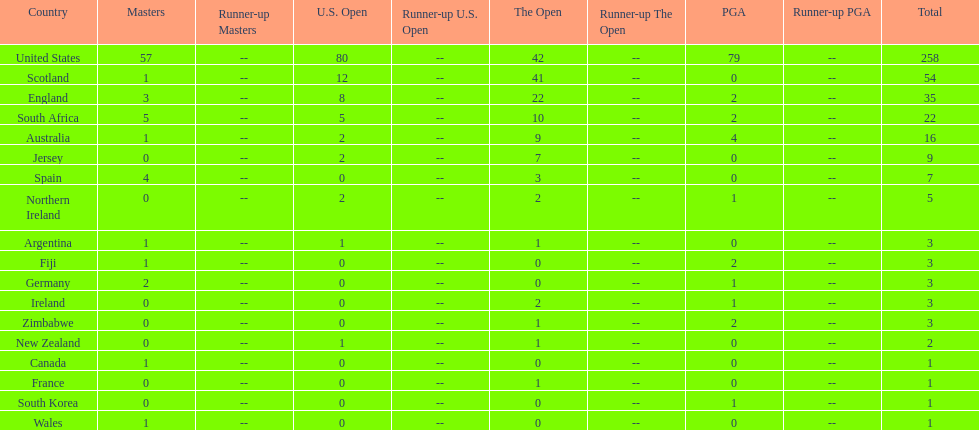How many u.s. open wins does fiji have? 0. Help me parse the entirety of this table. {'header': ['Country', 'Masters', 'Runner-up Masters', 'U.S. Open', 'Runner-up U.S. Open', 'The Open', 'Runner-up The Open', 'PGA', 'Runner-up PGA', 'Total'], 'rows': [['United States', '57', '--', '80', '--', '42', '--', '79', '--', '258'], ['Scotland', '1', '--', '12', '--', '41', '--', '0', '--', '54'], ['England', '3', '--', '8', '--', '22', '--', '2', '--', '35'], ['South Africa', '5', '--', '5', '--', '10', '--', '2', '--', '22'], ['Australia', '1', '--', '2', '--', '9', '--', '4', '--', '16'], ['Jersey', '0', '--', '2', '--', '7', '--', '0', '--', '9'], ['Spain', '4', '--', '0', '--', '3', '--', '0', '--', '7'], ['Northern Ireland', '0', '--', '2', '--', '2', '--', '1', '--', '5'], ['Argentina', '1', '--', '1', '--', '1', '--', '0', '--', '3'], ['Fiji', '1', '--', '0', '--', '0', '--', '2', '--', '3'], ['Germany', '2', '--', '0', '--', '0', '--', '1', '--', '3'], ['Ireland', '0', '--', '0', '--', '2', '--', '1', '--', '3'], ['Zimbabwe', '0', '--', '0', '--', '1', '--', '2', '--', '3'], ['New Zealand', '0', '--', '1', '--', '1', '--', '0', '--', '2'], ['Canada', '1', '--', '0', '--', '0', '--', '0', '--', '1'], ['France', '0', '--', '0', '--', '1', '--', '0', '--', '1'], ['South Korea', '0', '--', '0', '--', '0', '--', '1', '--', '1'], ['Wales', '1', '--', '0', '--', '0', '--', '0', '--', '1']]} 